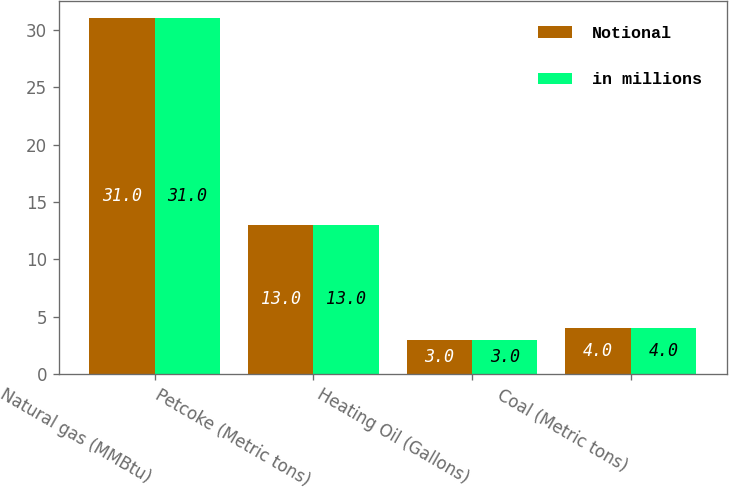Convert chart to OTSL. <chart><loc_0><loc_0><loc_500><loc_500><stacked_bar_chart><ecel><fcel>Natural gas (MMBtu)<fcel>Petcoke (Metric tons)<fcel>Heating Oil (Gallons)<fcel>Coal (Metric tons)<nl><fcel>Notional<fcel>31<fcel>13<fcel>3<fcel>4<nl><fcel>in millions<fcel>31<fcel>13<fcel>3<fcel>4<nl></chart> 